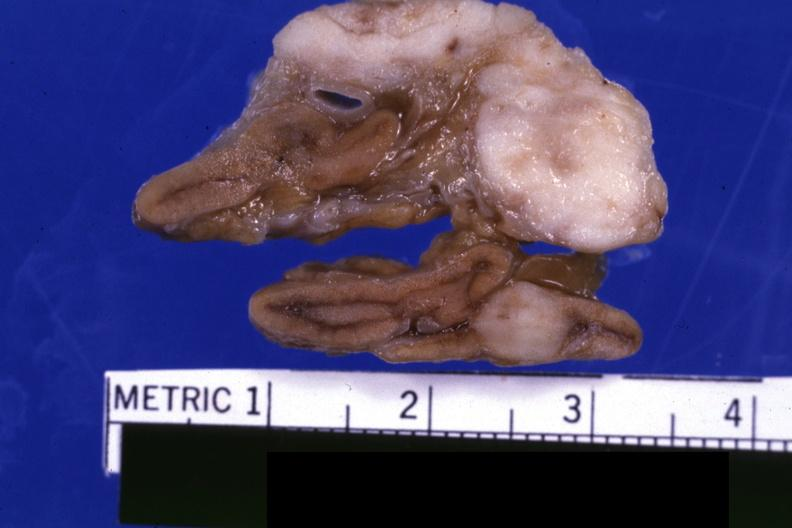what is present?
Answer the question using a single word or phrase. Endocrine 